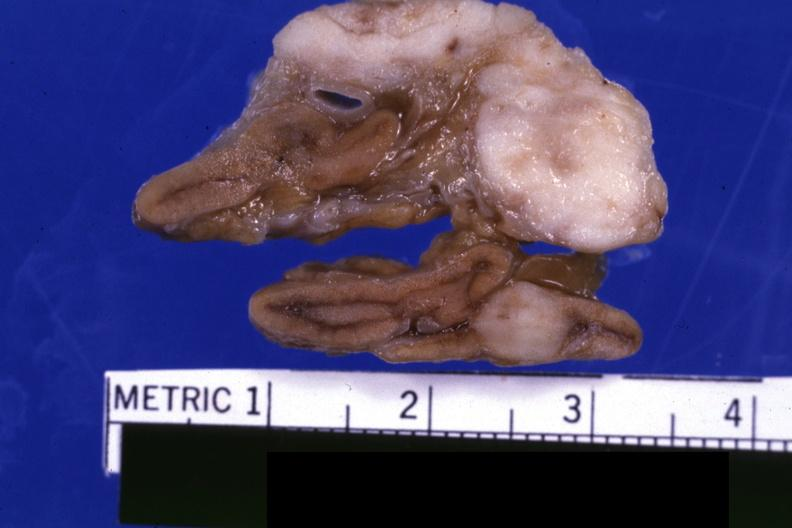what is present?
Answer the question using a single word or phrase. Endocrine 